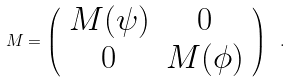<formula> <loc_0><loc_0><loc_500><loc_500>M = \left ( \begin{array} { c c } M ( \psi ) & 0 \\ 0 & M ( \phi ) \\ \end{array} \right ) \ .</formula> 